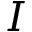<formula> <loc_0><loc_0><loc_500><loc_500>I</formula> 